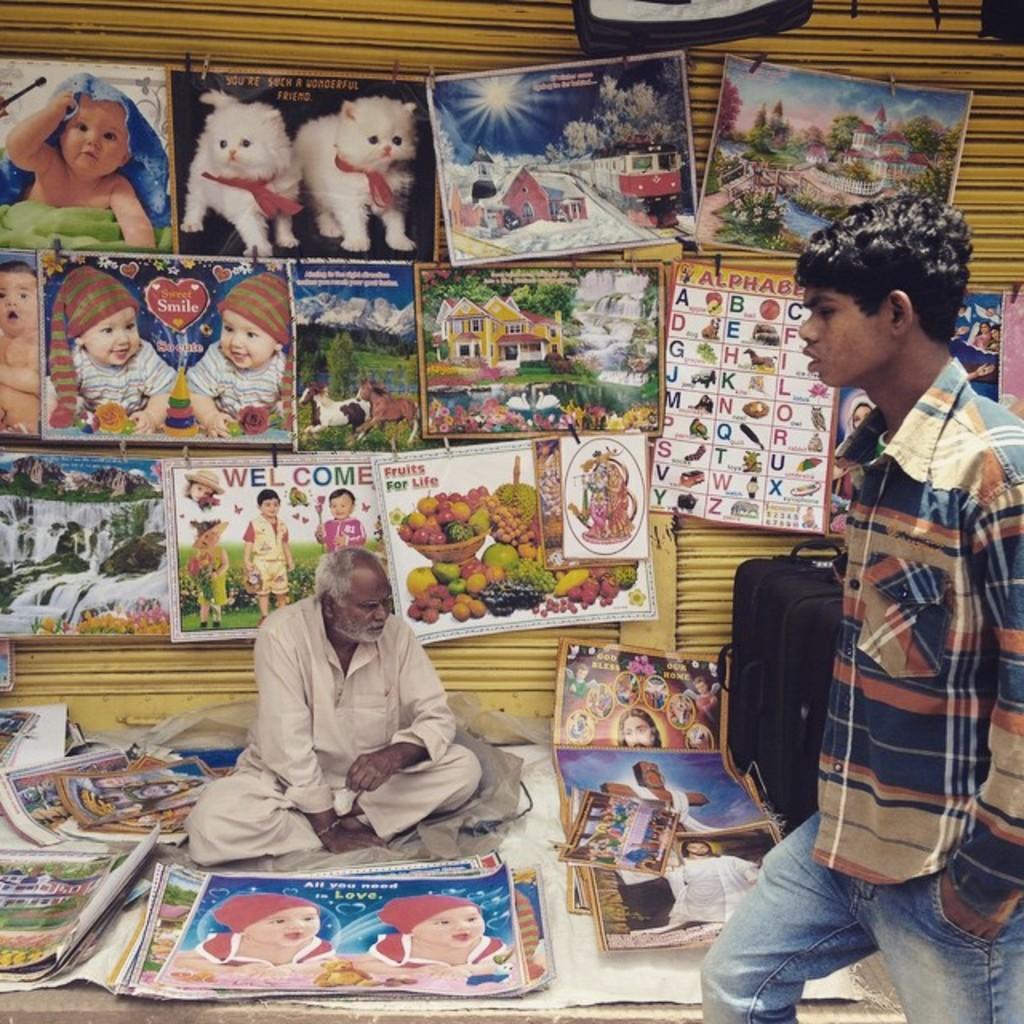Can you describe this image briefly? In the center we can see one person sitting on the floor. Around him we can see photos of babies,fruits,cats etc. On the right we can see one man standing. In the background there is a shutter and trolley. 